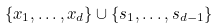Convert formula to latex. <formula><loc_0><loc_0><loc_500><loc_500>\{ x _ { 1 } , \dots , x _ { d } \} \cup \{ s _ { 1 } , \dots , s _ { d - 1 } \}</formula> 